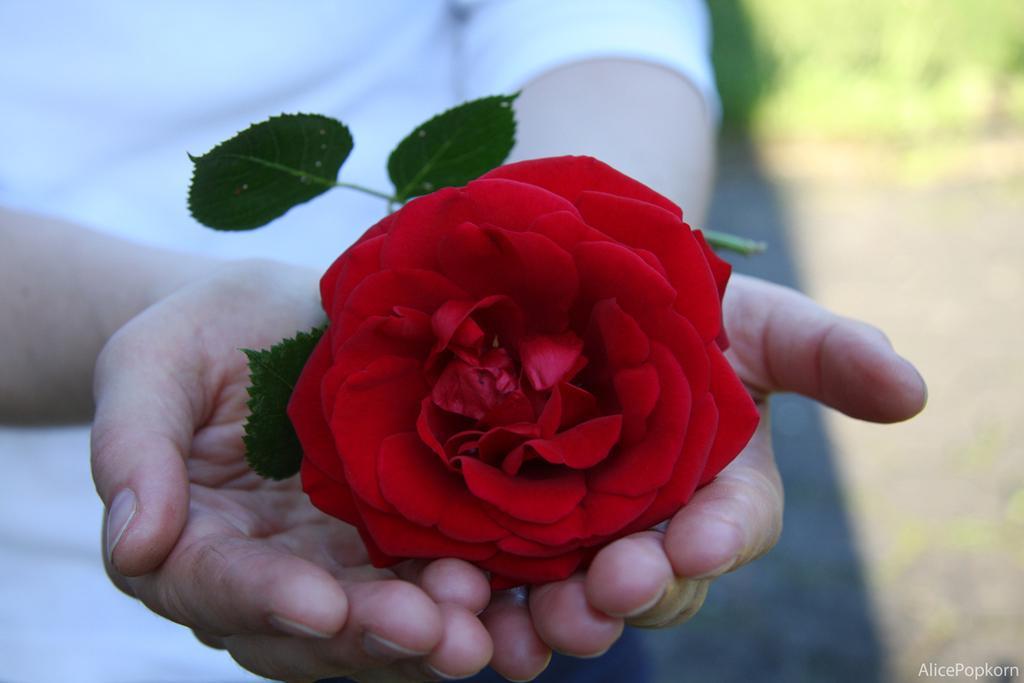Can you describe this image briefly? In this picture I can see a human holding rose flower in the hands and I can see a water mark at the bottom right corner of the picture. 